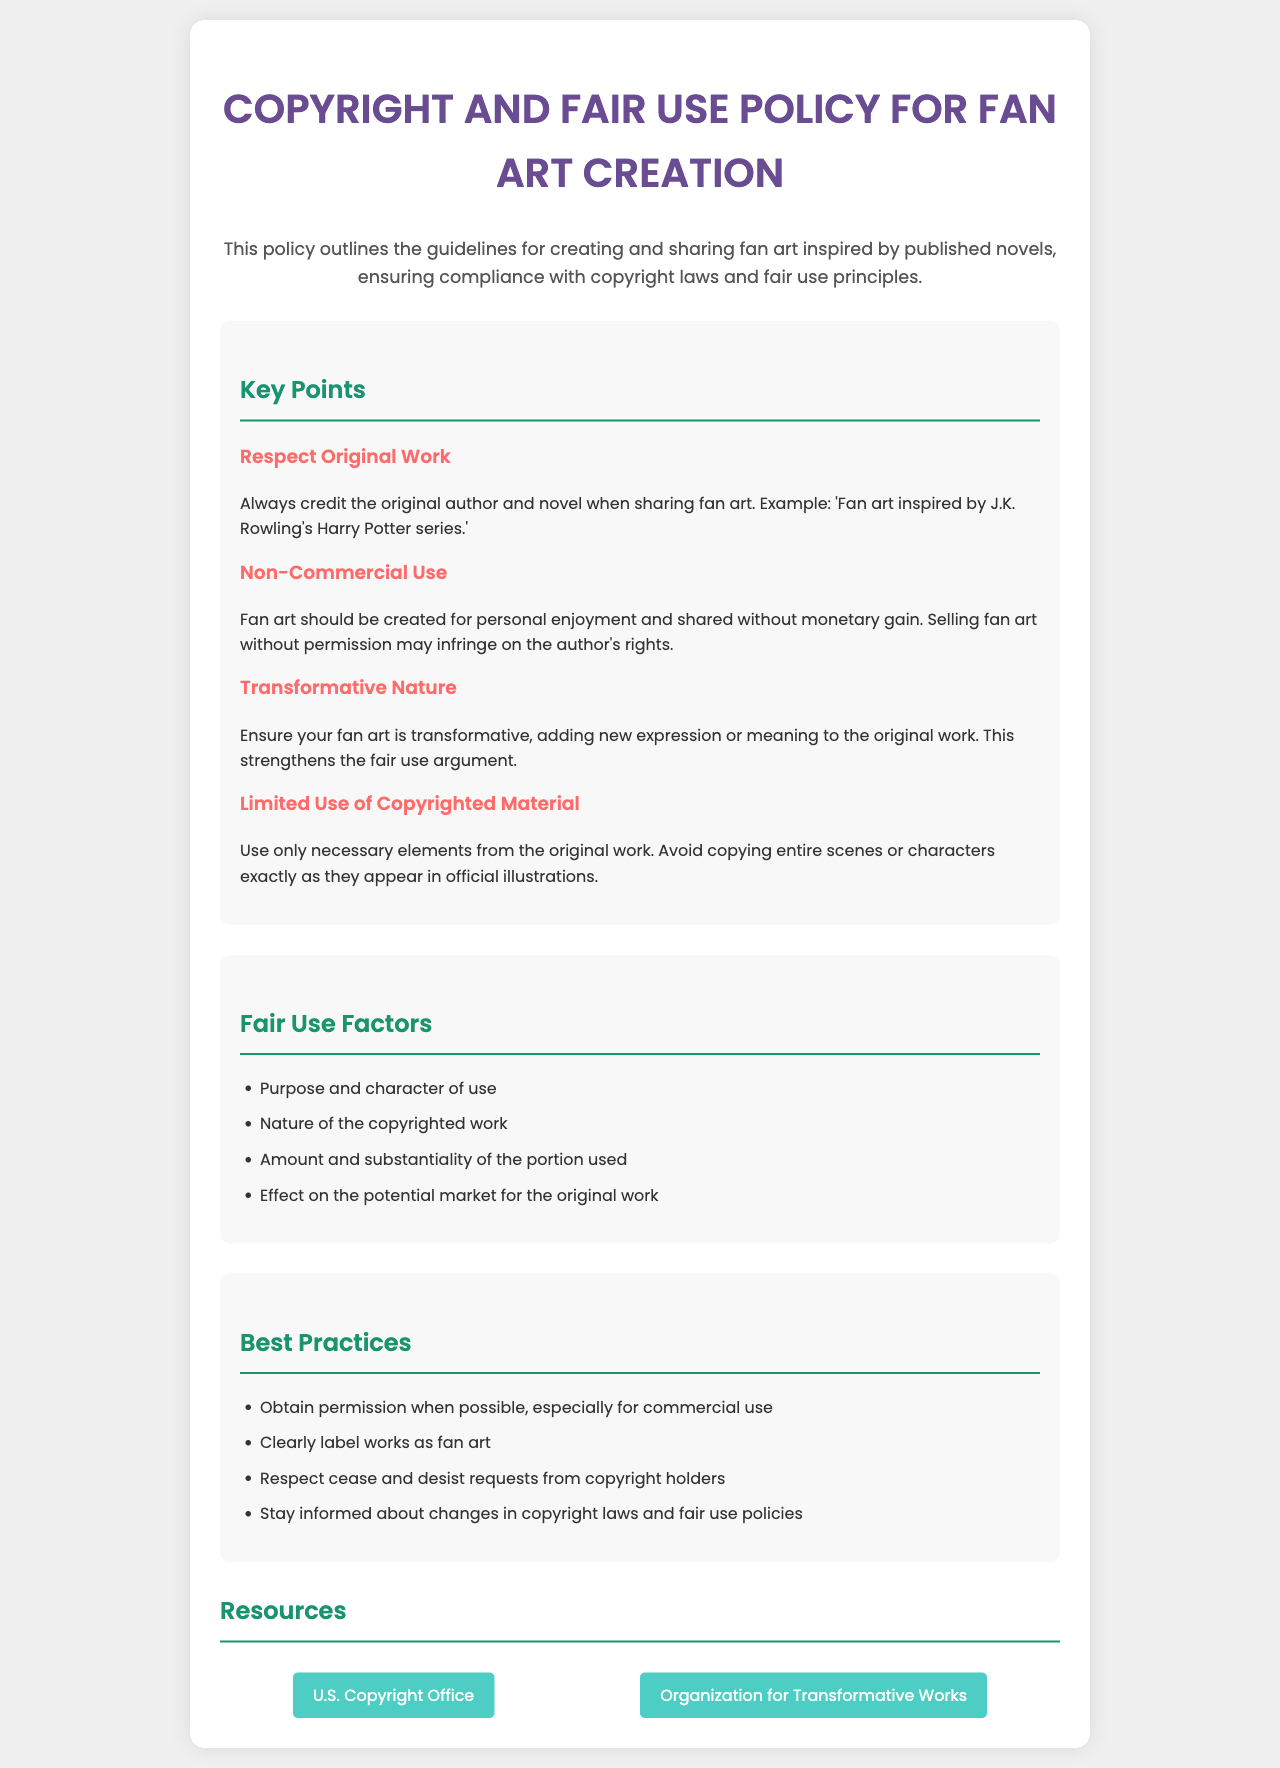What is the title of the document? The title is stated prominently at the top of the document in a header format.
Answer: Copyright and Fair Use Policy for Fan Art Creation What should you do when sharing fan art? The document advises that you should always credit the original author and novel.
Answer: Credit the original author What type of use is fan art intended for? The document mentions that fan art should be created for a specific purpose and that this type of use is non-commercial.
Answer: Non-commercial use What is one of the fair use factors? The document lists several fair use factors, one of which can be identified clearly.
Answer: Purpose and character of use What should you respect from copyright holders? The document advises respecting specific requests from copyright holders and provides guidance on how to interact with them.
Answer: Cease and desist requests What is one best practice mentioned in the document? The document provides a list of best practices, one of which stands out as important for creators.
Answer: Obtain permission What type of works should your fan art be identified as? The document emphasizes clarity when sharing your work based on its nature and purpose.
Answer: Fan art How many key points are listed in the document? The document presents a specific section with a count of distinct key points.
Answer: Four 